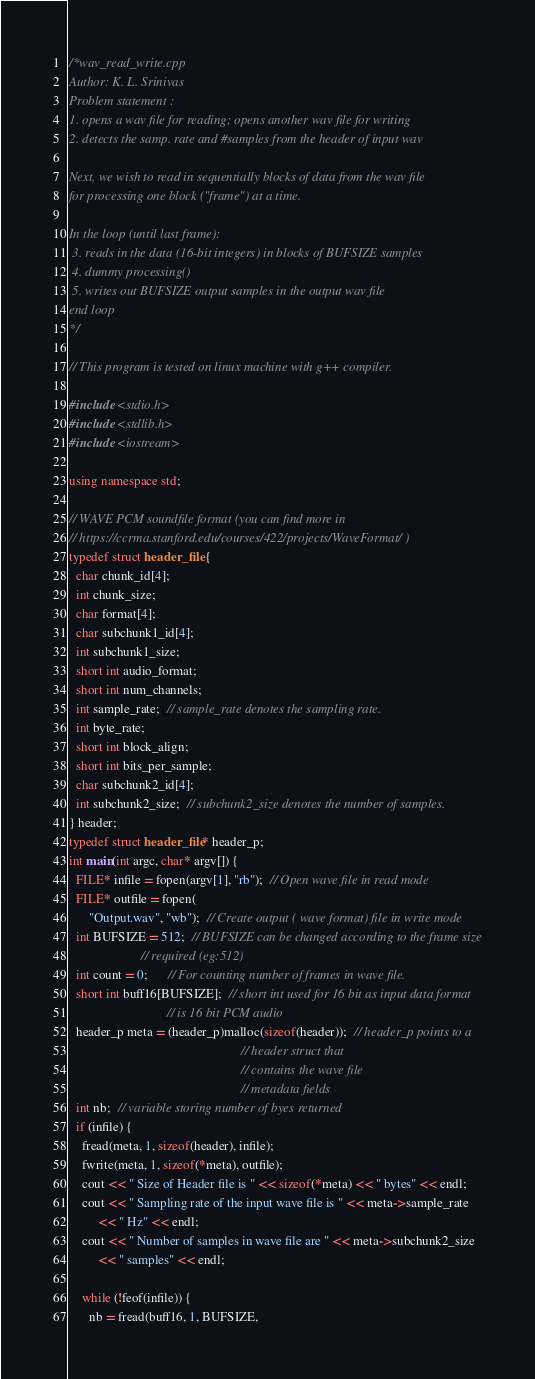<code> <loc_0><loc_0><loc_500><loc_500><_C++_>/*wav_read_write.cpp
Author: K. L. Srinivas
Problem statement :
1. opens a wav file for reading; opens another wav file for writing
2. detects the samp. rate and #samples from the header of input wav

Next, we wish to read in sequentially blocks of data from the wav file
for processing one block ("frame") at a time.

In the loop (until last frame):
 3. reads in the data (16-bit integers) in blocks of BUFSIZE samples
 4. dummy processing()
 5. writes out BUFSIZE output samples in the output wav file
end loop
*/

// This program is tested on linux machine with g++ compiler.

#include <stdio.h>
#include <stdlib.h>
#include <iostream>

using namespace std;

// WAVE PCM soundfile format (you can find more in
// https://ccrma.stanford.edu/courses/422/projects/WaveFormat/ )
typedef struct header_file {
  char chunk_id[4];
  int chunk_size;
  char format[4];
  char subchunk1_id[4];
  int subchunk1_size;
  short int audio_format;
  short int num_channels;
  int sample_rate;  // sample_rate denotes the sampling rate.
  int byte_rate;
  short int block_align;
  short int bits_per_sample;
  char subchunk2_id[4];
  int subchunk2_size;  // subchunk2_size denotes the number of samples.
} header;
typedef struct header_file* header_p;
int main(int argc, char* argv[]) {
  FILE* infile = fopen(argv[1], "rb");  // Open wave file in read mode
  FILE* outfile = fopen(
      "Output.wav", "wb");  // Create output ( wave format) file in write mode
  int BUFSIZE = 512;  // BUFSIZE can be changed according to the frame size
                      // required (eg:512)
  int count = 0;      // For counting number of frames in wave file.
  short int buff16[BUFSIZE];  // short int used for 16 bit as input data format
                              // is 16 bit PCM audio
  header_p meta = (header_p)malloc(sizeof(header));  // header_p points to a
                                                     // header struct that
                                                     // contains the wave file
                                                     // metadata fields
  int nb;  // variable storing number of byes returned
  if (infile) {
    fread(meta, 1, sizeof(header), infile);
    fwrite(meta, 1, sizeof(*meta), outfile);
    cout << " Size of Header file is " << sizeof(*meta) << " bytes" << endl;
    cout << " Sampling rate of the input wave file is " << meta->sample_rate
         << " Hz" << endl;
    cout << " Number of samples in wave file are " << meta->subchunk2_size
         << " samples" << endl;

    while (!feof(infile)) {
      nb = fread(buff16, 1, BUFSIZE,</code> 